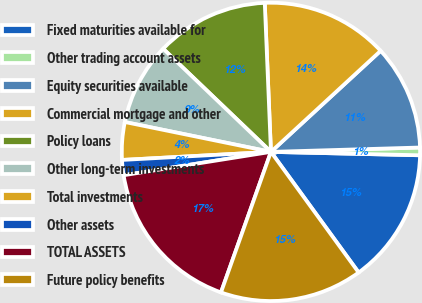Convert chart to OTSL. <chart><loc_0><loc_0><loc_500><loc_500><pie_chart><fcel>Fixed maturities available for<fcel>Other trading account assets<fcel>Equity securities available<fcel>Commercial mortgage and other<fcel>Policy loans<fcel>Other long-term investments<fcel>Total investments<fcel>Other assets<fcel>TOTAL ASSETS<fcel>Future policy benefits<nl><fcel>14.63%<fcel>0.83%<fcel>11.38%<fcel>13.81%<fcel>12.19%<fcel>8.94%<fcel>4.07%<fcel>1.64%<fcel>17.06%<fcel>15.44%<nl></chart> 